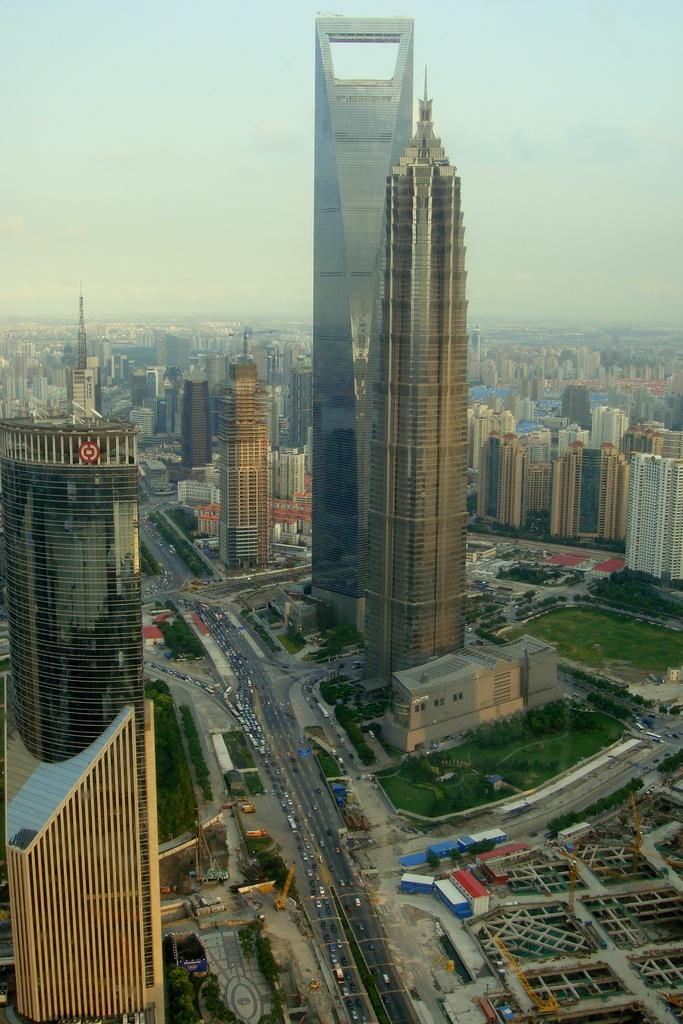What type of structures can be seen in the image? There are buildings in the image. What else is present in the image besides buildings? There are vehicles and grass visible in the image. Are there any living organisms in the image? Yes, there are plants in the image. What can be seen in the background of the image? The sky is visible in the background of the image. How many pies are being played on the drum in the image? There is no drum or pies present in the image. 